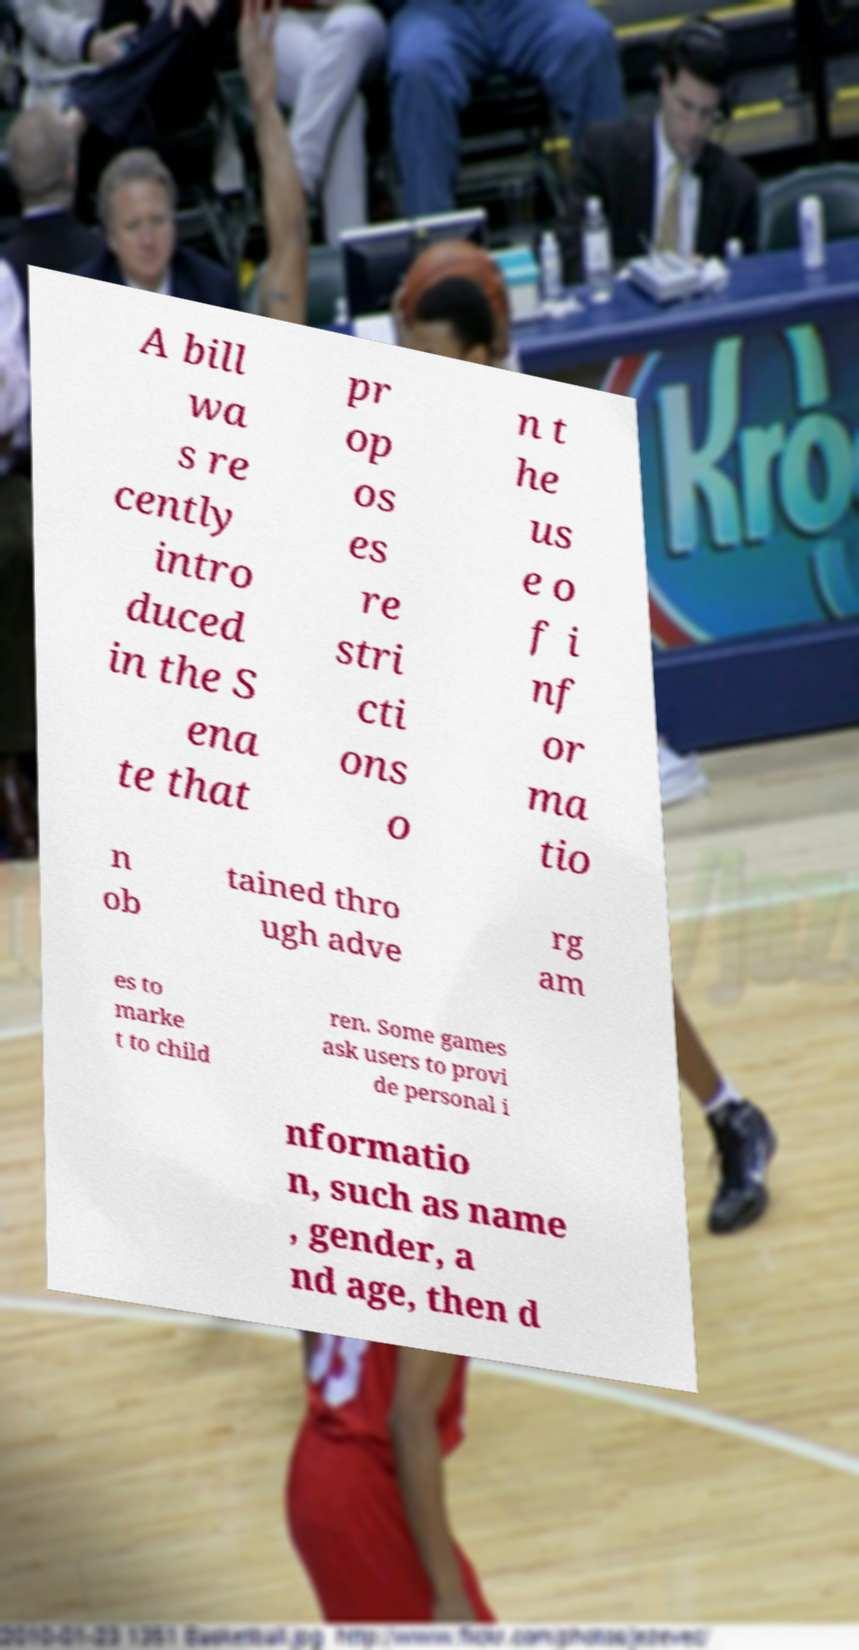Please read and relay the text visible in this image. What does it say? A bill wa s re cently intro duced in the S ena te that pr op os es re stri cti ons o n t he us e o f i nf or ma tio n ob tained thro ugh adve rg am es to marke t to child ren. Some games ask users to provi de personal i nformatio n, such as name , gender, a nd age, then d 